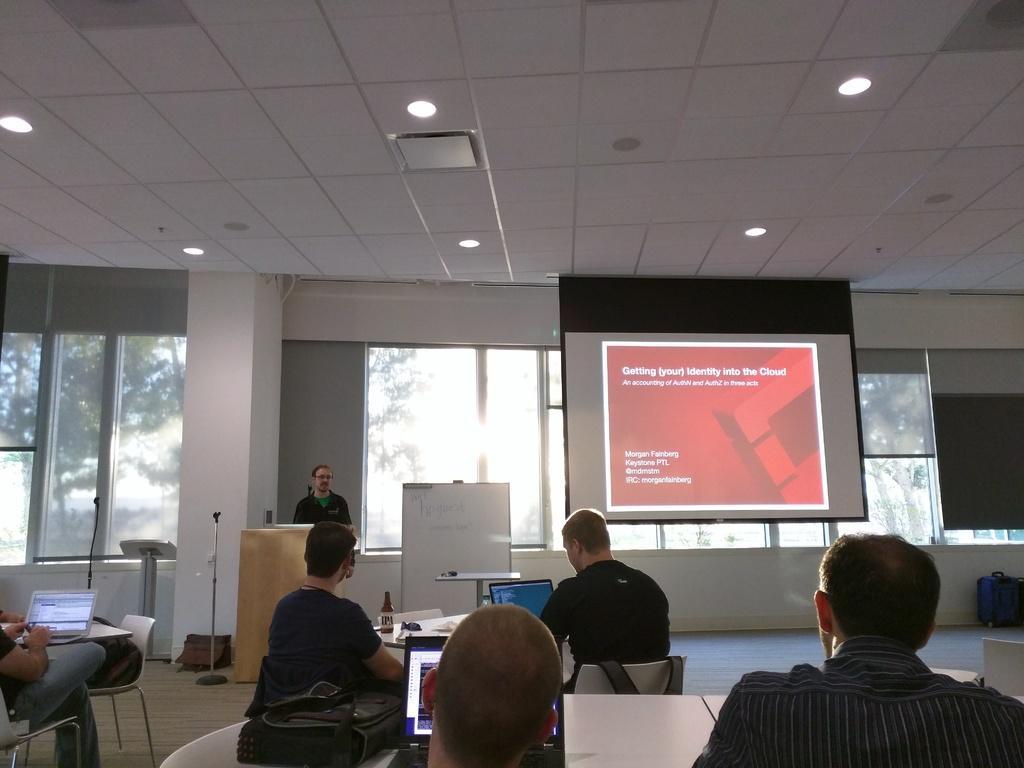Describe this image in one or two sentences. As we can see in the image there is a wall, window, roof, a screen, few people sitting on chairs and there is a table. On table there is a laptop, bottle and papers. 